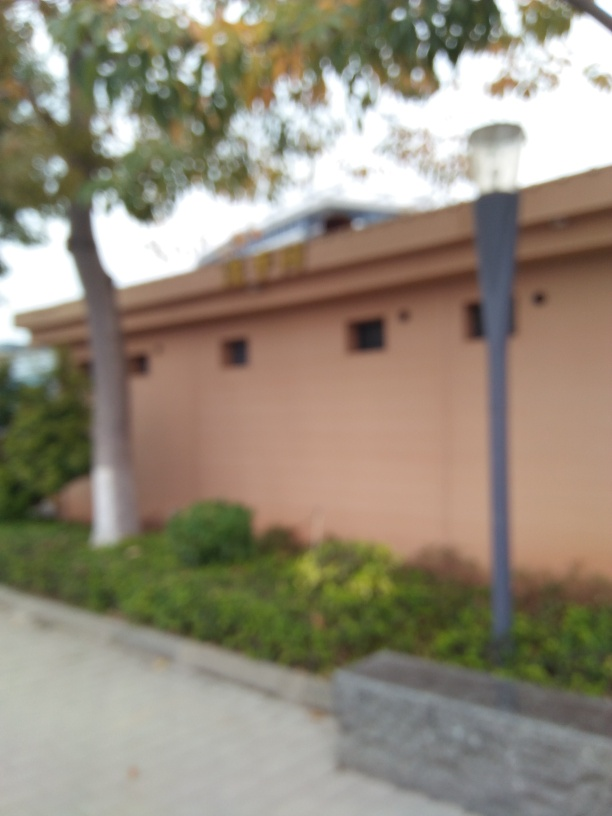How does the lighting affect the mood of the image? The diffuse lighting softens the image and contributes to a tranquil and serene mood. It smooths out any harsh shadows that might otherwise give a more dramatic or starker effect. The gentle light, in combination with the out-of-focus quality, can make the scene feel dreamlike or wistful. Could different weather conditions change the interpretation of this image? Absolutely. Bright sunlight or a clear blue sky could impart an energetic or vivacious mood, whereas overcast conditions or rain might heighten the sense of melancholy or introspection. Weather greatly influences the emotional tone of a photograph. 